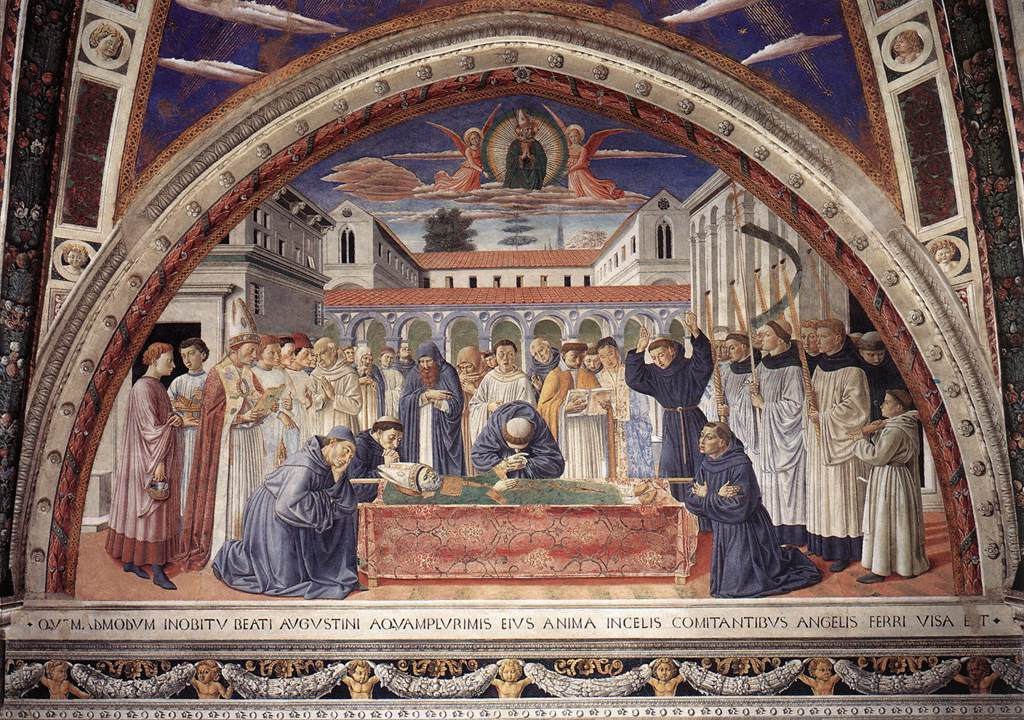Can you describe the expressions and emotions of the figures in this painting? The figures in the painting display a range of expressions and emotions, adding depth to the scene. The central figure, lying on a bed, appears peaceful, suggesting either sleep or death. Surrounding individuals exhibit sorrow and reverence; some bow their heads in prayer or contemplation, while others reach out with expressions of concern and care. Among the onlookers, a taller figure raises their hands, possibly in a gesture of supplication or blessing, indicating a significant or divine event. The emotion captured in their faces enhances the narrative, drawing the viewer into the solemn, poignant atmosphere of the fresco. What do the architectural features tell us about the setting of the scene? The architectural features in the background, including a large domed building and a pointed-roof structure, suggest a setting of importance, possibly religious or royal. The detailed arches, columns, and windows reflect Gothic architectural influence, emphasizing verticality and light. This grand setting implies that the event depicted is of significant importance, framed within an ornate and ceremonial environment typical of Gothic art's fascination with divine and royal subjects. What might the phrase 'QVI.M' symbolize in this painting? The phrase 'QVI.M' could hold various symbolic meanings, depending on the context of the painting. It might be an abbreviation or a specific reference pertinent to the historical or religious narrative depicted. It could denote a significant phrase or title, likely in Latin, given the period and style. Without further context, it's challenging to determine its exact meaning, but it undoubtedly adds an element of intrigue and invites viewers to delve deeper into the painting's symbolic and narrative layers. 